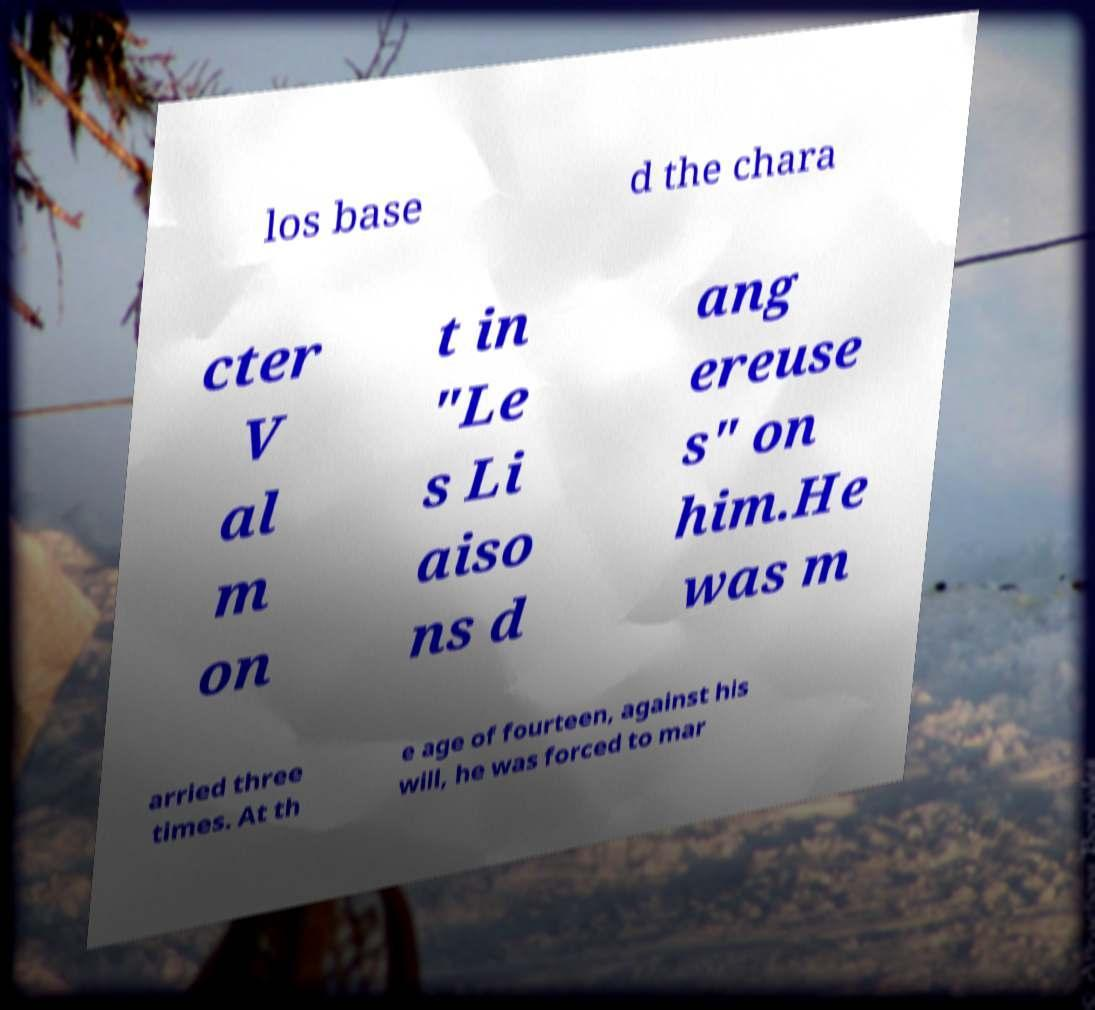Could you extract and type out the text from this image? los base d the chara cter V al m on t in "Le s Li aiso ns d ang ereuse s" on him.He was m arried three times. At th e age of fourteen, against his will, he was forced to mar 